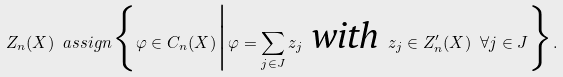<formula> <loc_0><loc_0><loc_500><loc_500>Z _ { n } ( X ) \ a s s i g n \Big \{ \varphi \in C _ { n } ( X ) \Big | \varphi = \sum _ { j \in J } z _ { j } \text { \em with } z _ { j } \in Z ^ { \prime } _ { n } ( X ) \ \forall j \in J \Big \} .</formula> 